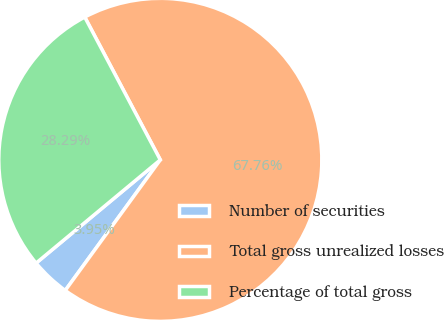Convert chart. <chart><loc_0><loc_0><loc_500><loc_500><pie_chart><fcel>Number of securities<fcel>Total gross unrealized losses<fcel>Percentage of total gross<nl><fcel>3.95%<fcel>67.76%<fcel>28.29%<nl></chart> 